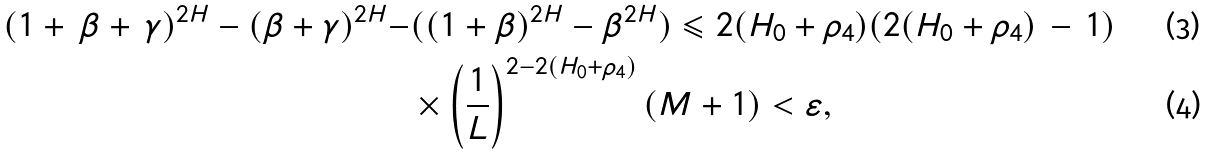Convert formula to latex. <formula><loc_0><loc_0><loc_500><loc_500>( 1 + \, \beta + \, \gamma ) ^ { 2 H } - ( \beta + \gamma ) ^ { 2 H } - & ( ( 1 + \beta ) ^ { 2 H } - \beta ^ { 2 H } ) \leqslant 2 ( H _ { 0 } + \rho _ { 4 } ) ( 2 ( H _ { 0 } + \rho _ { 4 } ) \, - \, 1 ) \\ & \times \left ( \frac { 1 } { L } \right ) ^ { 2 - 2 ( H _ { 0 } + \rho _ { 4 } ) } ( M + 1 ) < \varepsilon ,</formula> 